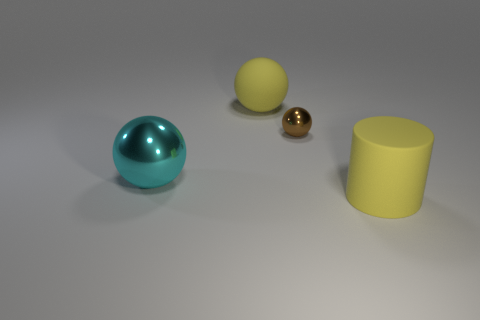Subtract all shiny balls. How many balls are left? 1 Subtract all cyan spheres. How many spheres are left? 2 Add 2 large rubber cylinders. How many objects exist? 6 Subtract 2 spheres. How many spheres are left? 1 Subtract all blue cylinders. How many green balls are left? 0 Subtract all brown objects. Subtract all large cyan metallic things. How many objects are left? 2 Add 3 yellow rubber cylinders. How many yellow rubber cylinders are left? 4 Add 2 small brown things. How many small brown things exist? 3 Subtract 1 yellow cylinders. How many objects are left? 3 Subtract all cylinders. How many objects are left? 3 